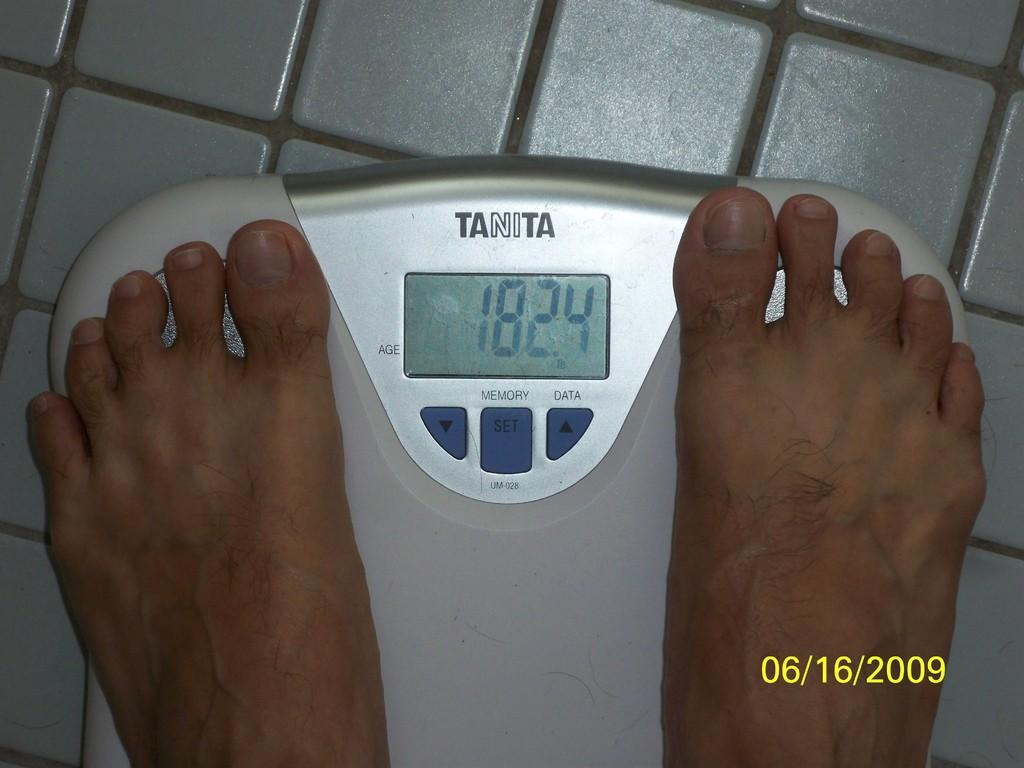Provide a one-sentence caption for the provided image. A persons feet are on s Tanita scale, showing 182.4 pounds. 